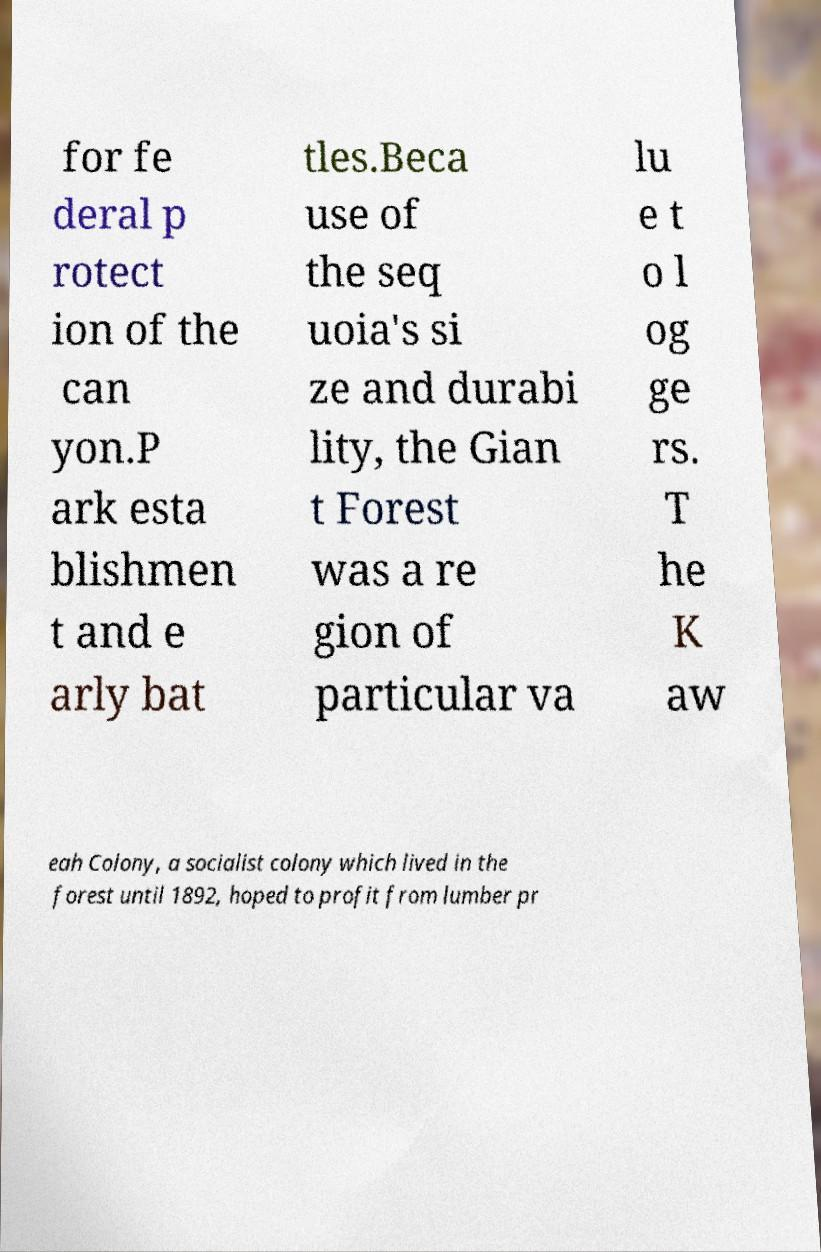Can you read and provide the text displayed in the image?This photo seems to have some interesting text. Can you extract and type it out for me? for fe deral p rotect ion of the can yon.P ark esta blishmen t and e arly bat tles.Beca use of the seq uoia's si ze and durabi lity, the Gian t Forest was a re gion of particular va lu e t o l og ge rs. T he K aw eah Colony, a socialist colony which lived in the forest until 1892, hoped to profit from lumber pr 